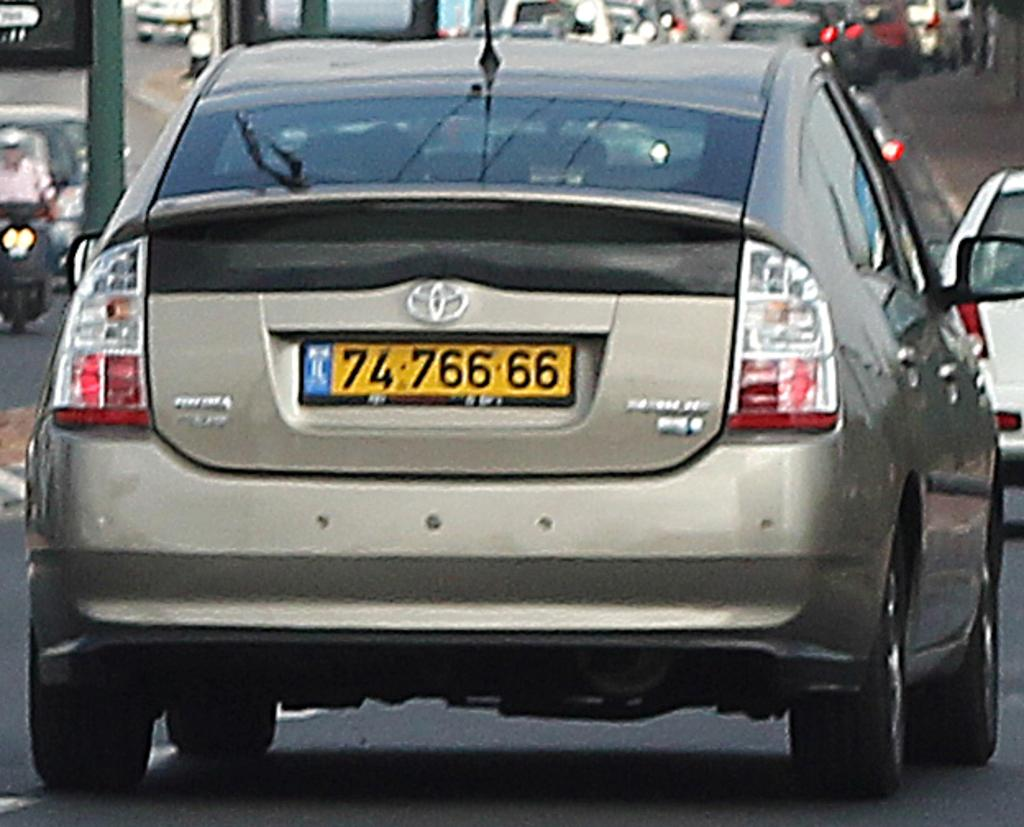<image>
Offer a succinct explanation of the picture presented. A grey Toyota with a yellow tag that reads 74766 66. 